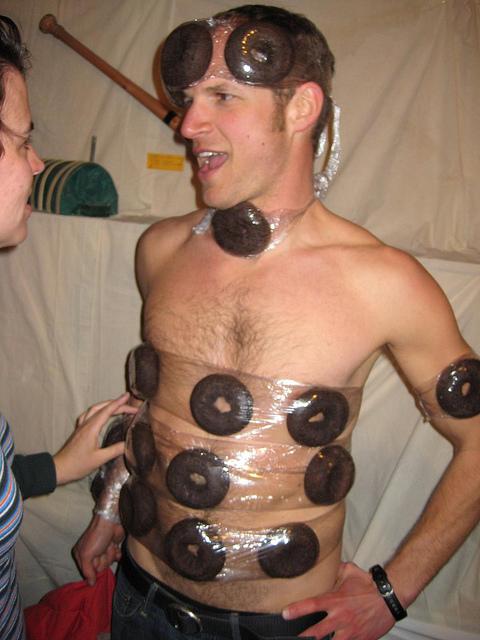Is this where doughnuts should be?
Short answer required. No. Is anyone wearing a watch?
Answer briefly. Yes. Is this a man or woman?
Quick response, please. Man. 